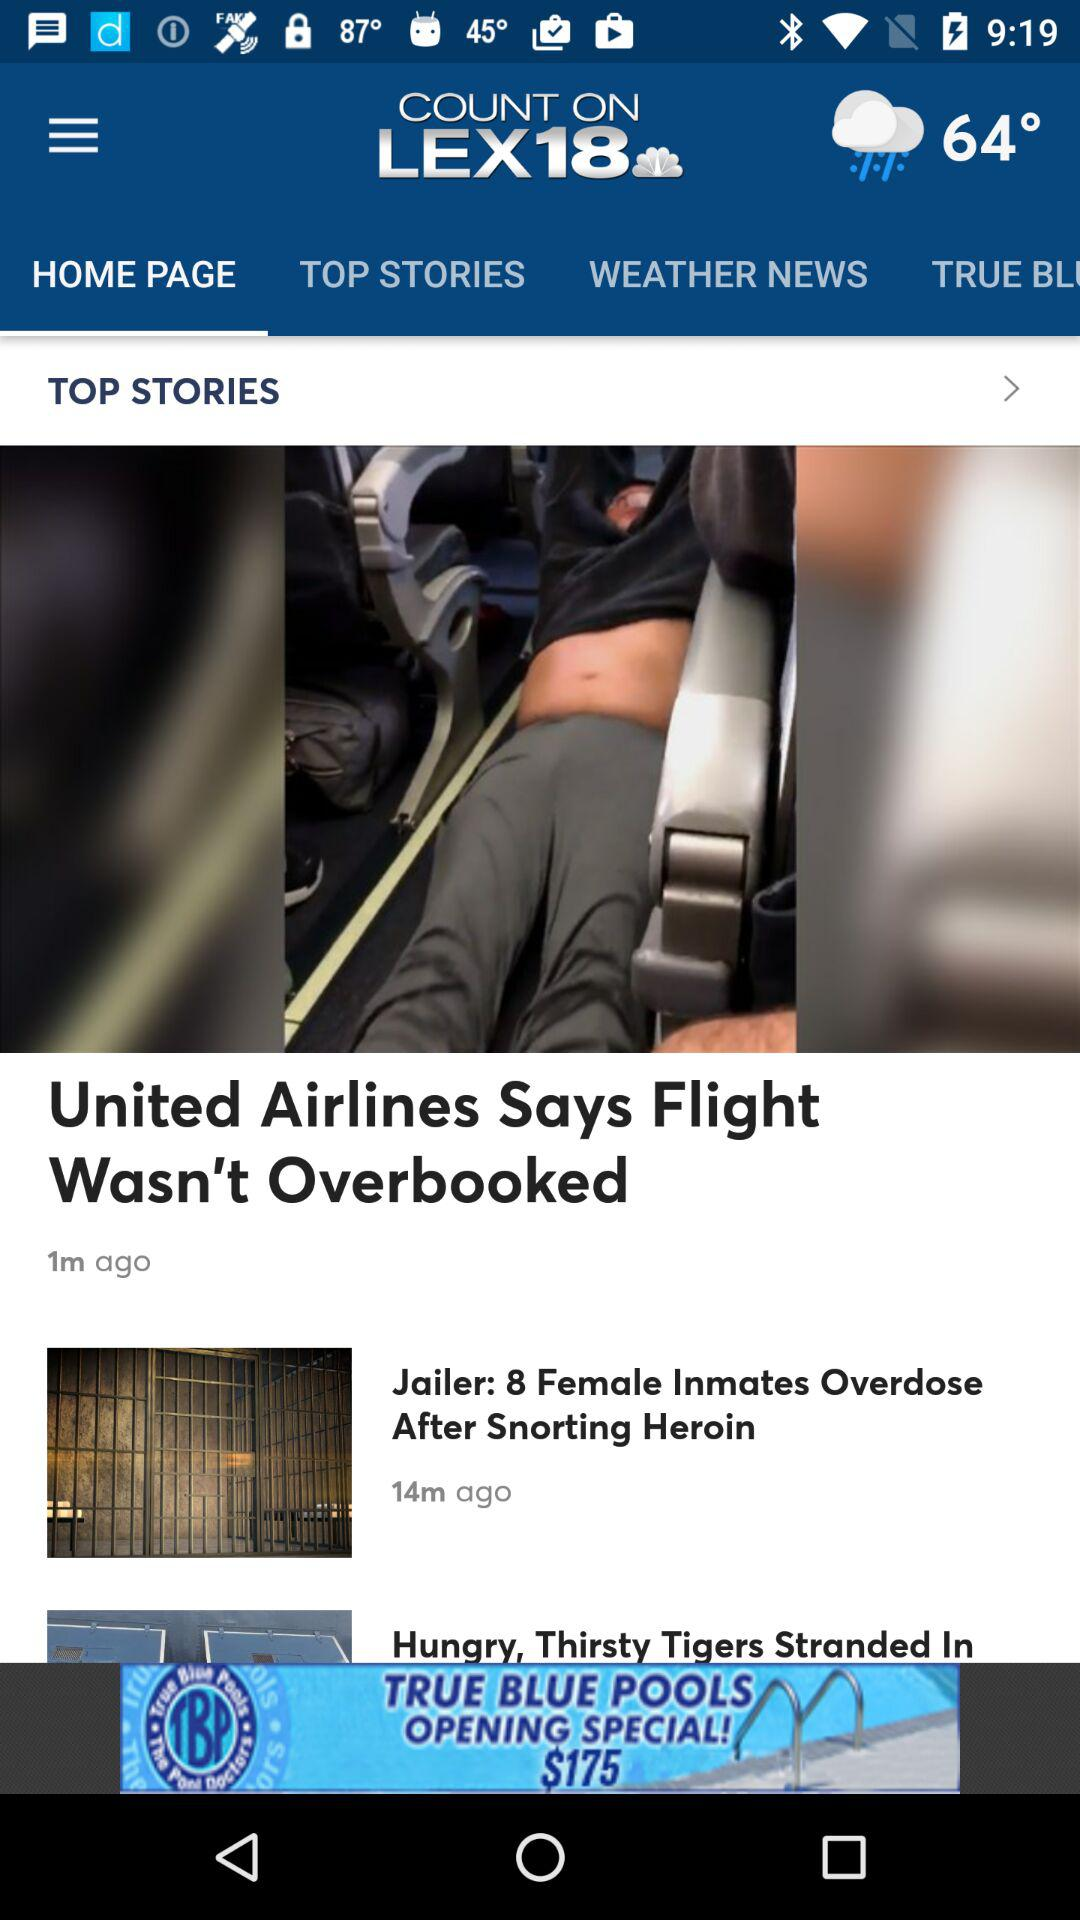What is the temperature? The temperature is 64°. 